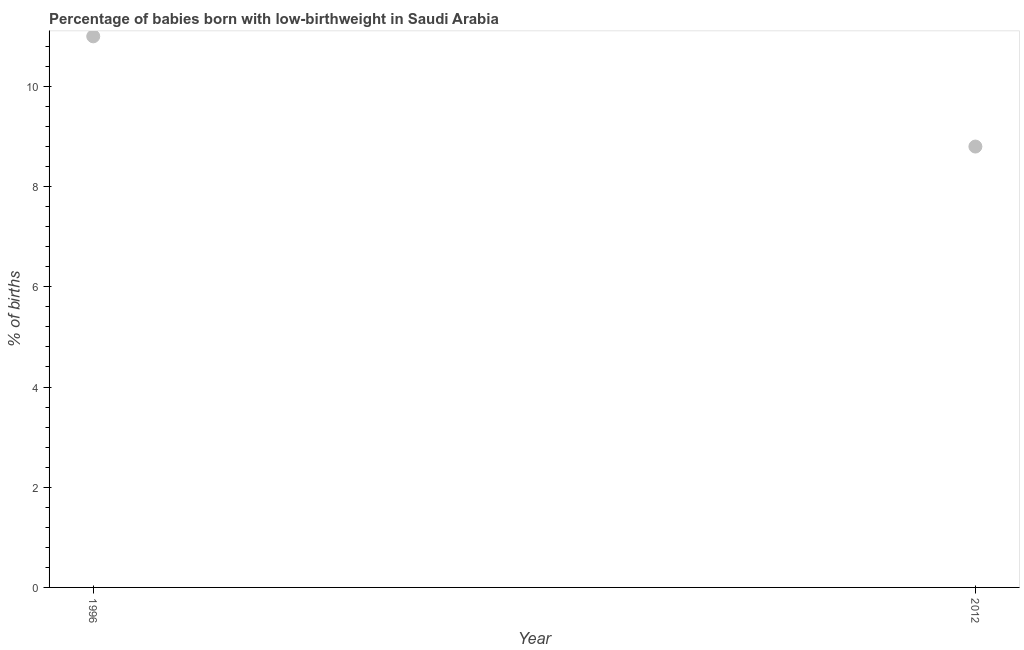What is the percentage of babies who were born with low-birthweight in 2012?
Your response must be concise. 8.8. Across all years, what is the maximum percentage of babies who were born with low-birthweight?
Provide a short and direct response. 11. Across all years, what is the minimum percentage of babies who were born with low-birthweight?
Provide a succinct answer. 8.8. In which year was the percentage of babies who were born with low-birthweight minimum?
Your answer should be very brief. 2012. What is the sum of the percentage of babies who were born with low-birthweight?
Provide a short and direct response. 19.8. What is the difference between the percentage of babies who were born with low-birthweight in 1996 and 2012?
Ensure brevity in your answer.  2.2. What is the ratio of the percentage of babies who were born with low-birthweight in 1996 to that in 2012?
Offer a very short reply. 1.25. In how many years, is the percentage of babies who were born with low-birthweight greater than the average percentage of babies who were born with low-birthweight taken over all years?
Provide a short and direct response. 1. How many years are there in the graph?
Your response must be concise. 2. What is the difference between two consecutive major ticks on the Y-axis?
Give a very brief answer. 2. What is the title of the graph?
Offer a terse response. Percentage of babies born with low-birthweight in Saudi Arabia. What is the label or title of the Y-axis?
Your response must be concise. % of births. What is the % of births in 1996?
Your response must be concise. 11. What is the % of births in 2012?
Your response must be concise. 8.8. What is the ratio of the % of births in 1996 to that in 2012?
Your answer should be very brief. 1.25. 